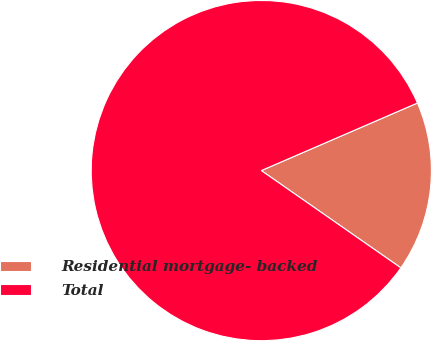<chart> <loc_0><loc_0><loc_500><loc_500><pie_chart><fcel>Residential mortgage- backed<fcel>Total<nl><fcel>16.19%<fcel>83.81%<nl></chart> 